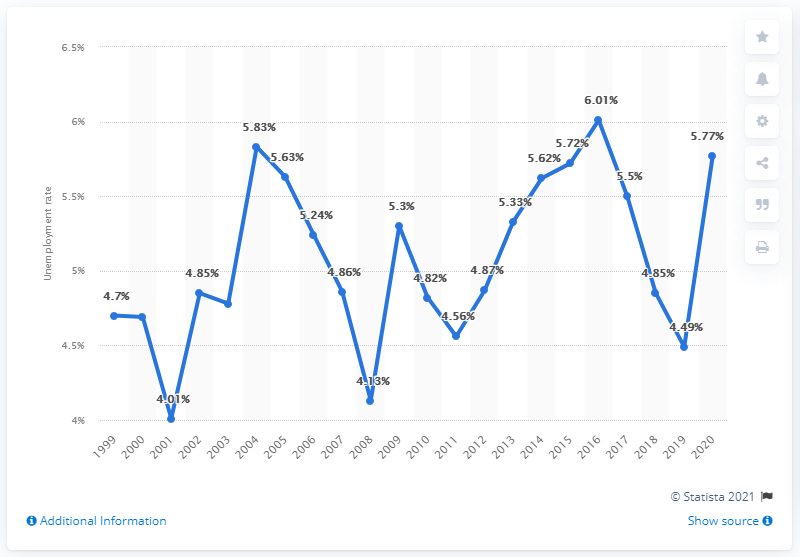Mention a couple of crucial points in this snapshot. The unemployment rate reached its peak in the year 2016. The unemployment rate increased by 1.28% between 2019 and 2020. 